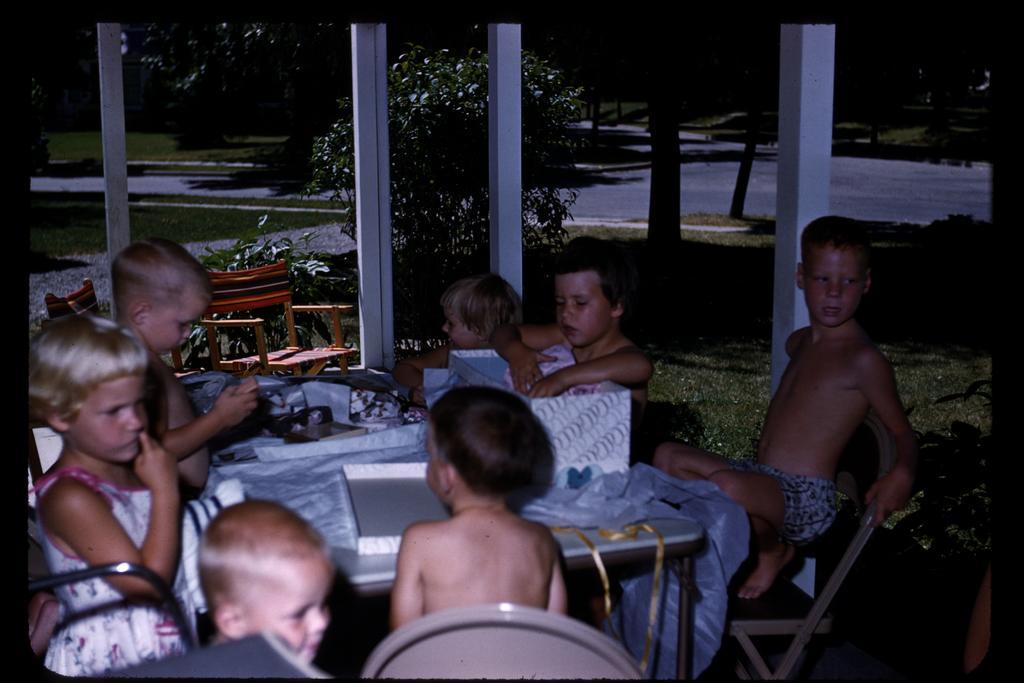In one or two sentences, can you explain what this image depicts? There are some children in this picture sitting in the chairs around the table on which some boxes were there. In the background there are some trees and a road here. 